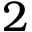<formula> <loc_0><loc_0><loc_500><loc_500>2</formula> 